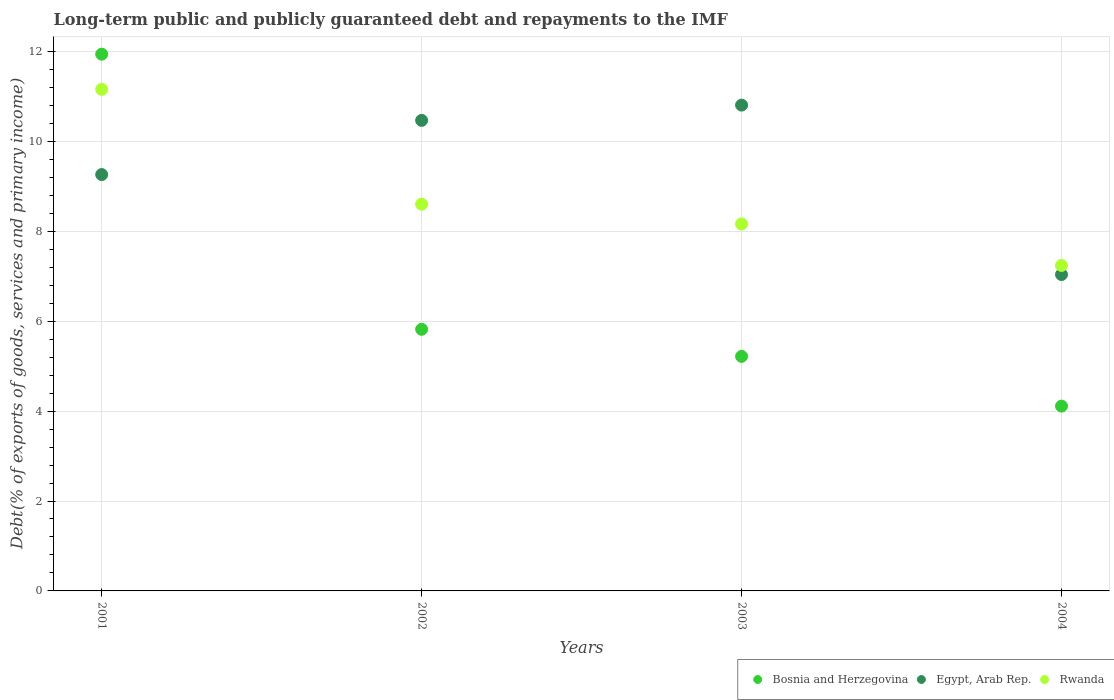How many different coloured dotlines are there?
Offer a terse response. 3. Is the number of dotlines equal to the number of legend labels?
Your answer should be compact. Yes. What is the debt and repayments in Egypt, Arab Rep. in 2003?
Your answer should be very brief. 10.81. Across all years, what is the maximum debt and repayments in Rwanda?
Offer a very short reply. 11.16. Across all years, what is the minimum debt and repayments in Rwanda?
Offer a terse response. 7.24. What is the total debt and repayments in Bosnia and Herzegovina in the graph?
Keep it short and to the point. 27.09. What is the difference between the debt and repayments in Rwanda in 2001 and that in 2004?
Keep it short and to the point. 3.92. What is the difference between the debt and repayments in Bosnia and Herzegovina in 2004 and the debt and repayments in Egypt, Arab Rep. in 2003?
Offer a very short reply. -6.7. What is the average debt and repayments in Bosnia and Herzegovina per year?
Offer a very short reply. 6.77. In the year 2004, what is the difference between the debt and repayments in Rwanda and debt and repayments in Egypt, Arab Rep.?
Give a very brief answer. 0.2. In how many years, is the debt and repayments in Rwanda greater than 10.4 %?
Ensure brevity in your answer.  1. What is the ratio of the debt and repayments in Egypt, Arab Rep. in 2002 to that in 2003?
Provide a short and direct response. 0.97. Is the debt and repayments in Bosnia and Herzegovina in 2001 less than that in 2002?
Your answer should be compact. No. What is the difference between the highest and the second highest debt and repayments in Bosnia and Herzegovina?
Your response must be concise. 6.12. What is the difference between the highest and the lowest debt and repayments in Bosnia and Herzegovina?
Provide a short and direct response. 7.83. In how many years, is the debt and repayments in Bosnia and Herzegovina greater than the average debt and repayments in Bosnia and Herzegovina taken over all years?
Your response must be concise. 1. Does the debt and repayments in Egypt, Arab Rep. monotonically increase over the years?
Provide a short and direct response. No. Is the debt and repayments in Rwanda strictly greater than the debt and repayments in Egypt, Arab Rep. over the years?
Provide a succinct answer. No. Is the debt and repayments in Bosnia and Herzegovina strictly less than the debt and repayments in Egypt, Arab Rep. over the years?
Make the answer very short. No. How many dotlines are there?
Offer a very short reply. 3. Are the values on the major ticks of Y-axis written in scientific E-notation?
Offer a terse response. No. Does the graph contain any zero values?
Your answer should be very brief. No. Where does the legend appear in the graph?
Keep it short and to the point. Bottom right. What is the title of the graph?
Provide a short and direct response. Long-term public and publicly guaranteed debt and repayments to the IMF. Does "Tonga" appear as one of the legend labels in the graph?
Give a very brief answer. No. What is the label or title of the X-axis?
Offer a very short reply. Years. What is the label or title of the Y-axis?
Give a very brief answer. Debt(% of exports of goods, services and primary income). What is the Debt(% of exports of goods, services and primary income) in Bosnia and Herzegovina in 2001?
Provide a succinct answer. 11.94. What is the Debt(% of exports of goods, services and primary income) in Egypt, Arab Rep. in 2001?
Your answer should be very brief. 9.26. What is the Debt(% of exports of goods, services and primary income) of Rwanda in 2001?
Give a very brief answer. 11.16. What is the Debt(% of exports of goods, services and primary income) of Bosnia and Herzegovina in 2002?
Ensure brevity in your answer.  5.82. What is the Debt(% of exports of goods, services and primary income) of Egypt, Arab Rep. in 2002?
Your answer should be very brief. 10.47. What is the Debt(% of exports of goods, services and primary income) in Rwanda in 2002?
Give a very brief answer. 8.6. What is the Debt(% of exports of goods, services and primary income) of Bosnia and Herzegovina in 2003?
Offer a very short reply. 5.22. What is the Debt(% of exports of goods, services and primary income) in Egypt, Arab Rep. in 2003?
Offer a very short reply. 10.81. What is the Debt(% of exports of goods, services and primary income) of Rwanda in 2003?
Make the answer very short. 8.16. What is the Debt(% of exports of goods, services and primary income) of Bosnia and Herzegovina in 2004?
Provide a short and direct response. 4.11. What is the Debt(% of exports of goods, services and primary income) of Egypt, Arab Rep. in 2004?
Make the answer very short. 7.04. What is the Debt(% of exports of goods, services and primary income) of Rwanda in 2004?
Your answer should be very brief. 7.24. Across all years, what is the maximum Debt(% of exports of goods, services and primary income) of Bosnia and Herzegovina?
Keep it short and to the point. 11.94. Across all years, what is the maximum Debt(% of exports of goods, services and primary income) of Egypt, Arab Rep.?
Make the answer very short. 10.81. Across all years, what is the maximum Debt(% of exports of goods, services and primary income) in Rwanda?
Give a very brief answer. 11.16. Across all years, what is the minimum Debt(% of exports of goods, services and primary income) in Bosnia and Herzegovina?
Your answer should be very brief. 4.11. Across all years, what is the minimum Debt(% of exports of goods, services and primary income) of Egypt, Arab Rep.?
Your response must be concise. 7.04. Across all years, what is the minimum Debt(% of exports of goods, services and primary income) of Rwanda?
Offer a very short reply. 7.24. What is the total Debt(% of exports of goods, services and primary income) of Bosnia and Herzegovina in the graph?
Offer a very short reply. 27.09. What is the total Debt(% of exports of goods, services and primary income) in Egypt, Arab Rep. in the graph?
Make the answer very short. 37.58. What is the total Debt(% of exports of goods, services and primary income) of Rwanda in the graph?
Your response must be concise. 35.17. What is the difference between the Debt(% of exports of goods, services and primary income) of Bosnia and Herzegovina in 2001 and that in 2002?
Your answer should be very brief. 6.12. What is the difference between the Debt(% of exports of goods, services and primary income) of Egypt, Arab Rep. in 2001 and that in 2002?
Ensure brevity in your answer.  -1.21. What is the difference between the Debt(% of exports of goods, services and primary income) of Rwanda in 2001 and that in 2002?
Keep it short and to the point. 2.55. What is the difference between the Debt(% of exports of goods, services and primary income) of Bosnia and Herzegovina in 2001 and that in 2003?
Give a very brief answer. 6.72. What is the difference between the Debt(% of exports of goods, services and primary income) in Egypt, Arab Rep. in 2001 and that in 2003?
Make the answer very short. -1.55. What is the difference between the Debt(% of exports of goods, services and primary income) of Rwanda in 2001 and that in 2003?
Offer a terse response. 2.99. What is the difference between the Debt(% of exports of goods, services and primary income) of Bosnia and Herzegovina in 2001 and that in 2004?
Your response must be concise. 7.83. What is the difference between the Debt(% of exports of goods, services and primary income) of Egypt, Arab Rep. in 2001 and that in 2004?
Your response must be concise. 2.22. What is the difference between the Debt(% of exports of goods, services and primary income) in Rwanda in 2001 and that in 2004?
Your answer should be very brief. 3.92. What is the difference between the Debt(% of exports of goods, services and primary income) in Bosnia and Herzegovina in 2002 and that in 2003?
Your answer should be compact. 0.6. What is the difference between the Debt(% of exports of goods, services and primary income) in Egypt, Arab Rep. in 2002 and that in 2003?
Offer a terse response. -0.34. What is the difference between the Debt(% of exports of goods, services and primary income) in Rwanda in 2002 and that in 2003?
Ensure brevity in your answer.  0.44. What is the difference between the Debt(% of exports of goods, services and primary income) in Bosnia and Herzegovina in 2002 and that in 2004?
Your response must be concise. 1.71. What is the difference between the Debt(% of exports of goods, services and primary income) in Egypt, Arab Rep. in 2002 and that in 2004?
Give a very brief answer. 3.43. What is the difference between the Debt(% of exports of goods, services and primary income) of Rwanda in 2002 and that in 2004?
Ensure brevity in your answer.  1.36. What is the difference between the Debt(% of exports of goods, services and primary income) in Bosnia and Herzegovina in 2003 and that in 2004?
Keep it short and to the point. 1.11. What is the difference between the Debt(% of exports of goods, services and primary income) in Egypt, Arab Rep. in 2003 and that in 2004?
Give a very brief answer. 3.77. What is the difference between the Debt(% of exports of goods, services and primary income) of Rwanda in 2003 and that in 2004?
Ensure brevity in your answer.  0.92. What is the difference between the Debt(% of exports of goods, services and primary income) in Bosnia and Herzegovina in 2001 and the Debt(% of exports of goods, services and primary income) in Egypt, Arab Rep. in 2002?
Ensure brevity in your answer.  1.47. What is the difference between the Debt(% of exports of goods, services and primary income) in Bosnia and Herzegovina in 2001 and the Debt(% of exports of goods, services and primary income) in Rwanda in 2002?
Make the answer very short. 3.34. What is the difference between the Debt(% of exports of goods, services and primary income) of Egypt, Arab Rep. in 2001 and the Debt(% of exports of goods, services and primary income) of Rwanda in 2002?
Provide a short and direct response. 0.66. What is the difference between the Debt(% of exports of goods, services and primary income) of Bosnia and Herzegovina in 2001 and the Debt(% of exports of goods, services and primary income) of Egypt, Arab Rep. in 2003?
Make the answer very short. 1.13. What is the difference between the Debt(% of exports of goods, services and primary income) in Bosnia and Herzegovina in 2001 and the Debt(% of exports of goods, services and primary income) in Rwanda in 2003?
Your response must be concise. 3.78. What is the difference between the Debt(% of exports of goods, services and primary income) in Egypt, Arab Rep. in 2001 and the Debt(% of exports of goods, services and primary income) in Rwanda in 2003?
Offer a very short reply. 1.1. What is the difference between the Debt(% of exports of goods, services and primary income) in Bosnia and Herzegovina in 2001 and the Debt(% of exports of goods, services and primary income) in Egypt, Arab Rep. in 2004?
Keep it short and to the point. 4.9. What is the difference between the Debt(% of exports of goods, services and primary income) in Bosnia and Herzegovina in 2001 and the Debt(% of exports of goods, services and primary income) in Rwanda in 2004?
Ensure brevity in your answer.  4.7. What is the difference between the Debt(% of exports of goods, services and primary income) in Egypt, Arab Rep. in 2001 and the Debt(% of exports of goods, services and primary income) in Rwanda in 2004?
Provide a succinct answer. 2.02. What is the difference between the Debt(% of exports of goods, services and primary income) of Bosnia and Herzegovina in 2002 and the Debt(% of exports of goods, services and primary income) of Egypt, Arab Rep. in 2003?
Your answer should be compact. -4.99. What is the difference between the Debt(% of exports of goods, services and primary income) of Bosnia and Herzegovina in 2002 and the Debt(% of exports of goods, services and primary income) of Rwanda in 2003?
Make the answer very short. -2.34. What is the difference between the Debt(% of exports of goods, services and primary income) in Egypt, Arab Rep. in 2002 and the Debt(% of exports of goods, services and primary income) in Rwanda in 2003?
Give a very brief answer. 2.3. What is the difference between the Debt(% of exports of goods, services and primary income) in Bosnia and Herzegovina in 2002 and the Debt(% of exports of goods, services and primary income) in Egypt, Arab Rep. in 2004?
Ensure brevity in your answer.  -1.22. What is the difference between the Debt(% of exports of goods, services and primary income) in Bosnia and Herzegovina in 2002 and the Debt(% of exports of goods, services and primary income) in Rwanda in 2004?
Keep it short and to the point. -1.42. What is the difference between the Debt(% of exports of goods, services and primary income) in Egypt, Arab Rep. in 2002 and the Debt(% of exports of goods, services and primary income) in Rwanda in 2004?
Provide a succinct answer. 3.23. What is the difference between the Debt(% of exports of goods, services and primary income) in Bosnia and Herzegovina in 2003 and the Debt(% of exports of goods, services and primary income) in Egypt, Arab Rep. in 2004?
Keep it short and to the point. -1.82. What is the difference between the Debt(% of exports of goods, services and primary income) in Bosnia and Herzegovina in 2003 and the Debt(% of exports of goods, services and primary income) in Rwanda in 2004?
Offer a terse response. -2.02. What is the difference between the Debt(% of exports of goods, services and primary income) in Egypt, Arab Rep. in 2003 and the Debt(% of exports of goods, services and primary income) in Rwanda in 2004?
Provide a succinct answer. 3.57. What is the average Debt(% of exports of goods, services and primary income) of Bosnia and Herzegovina per year?
Keep it short and to the point. 6.77. What is the average Debt(% of exports of goods, services and primary income) in Egypt, Arab Rep. per year?
Offer a terse response. 9.39. What is the average Debt(% of exports of goods, services and primary income) in Rwanda per year?
Keep it short and to the point. 8.79. In the year 2001, what is the difference between the Debt(% of exports of goods, services and primary income) of Bosnia and Herzegovina and Debt(% of exports of goods, services and primary income) of Egypt, Arab Rep.?
Provide a succinct answer. 2.68. In the year 2001, what is the difference between the Debt(% of exports of goods, services and primary income) in Bosnia and Herzegovina and Debt(% of exports of goods, services and primary income) in Rwanda?
Your answer should be very brief. 0.78. In the year 2001, what is the difference between the Debt(% of exports of goods, services and primary income) in Egypt, Arab Rep. and Debt(% of exports of goods, services and primary income) in Rwanda?
Offer a terse response. -1.9. In the year 2002, what is the difference between the Debt(% of exports of goods, services and primary income) in Bosnia and Herzegovina and Debt(% of exports of goods, services and primary income) in Egypt, Arab Rep.?
Provide a succinct answer. -4.65. In the year 2002, what is the difference between the Debt(% of exports of goods, services and primary income) in Bosnia and Herzegovina and Debt(% of exports of goods, services and primary income) in Rwanda?
Your response must be concise. -2.78. In the year 2002, what is the difference between the Debt(% of exports of goods, services and primary income) in Egypt, Arab Rep. and Debt(% of exports of goods, services and primary income) in Rwanda?
Your answer should be compact. 1.86. In the year 2003, what is the difference between the Debt(% of exports of goods, services and primary income) of Bosnia and Herzegovina and Debt(% of exports of goods, services and primary income) of Egypt, Arab Rep.?
Make the answer very short. -5.59. In the year 2003, what is the difference between the Debt(% of exports of goods, services and primary income) of Bosnia and Herzegovina and Debt(% of exports of goods, services and primary income) of Rwanda?
Make the answer very short. -2.95. In the year 2003, what is the difference between the Debt(% of exports of goods, services and primary income) of Egypt, Arab Rep. and Debt(% of exports of goods, services and primary income) of Rwanda?
Provide a short and direct response. 2.64. In the year 2004, what is the difference between the Debt(% of exports of goods, services and primary income) of Bosnia and Herzegovina and Debt(% of exports of goods, services and primary income) of Egypt, Arab Rep.?
Ensure brevity in your answer.  -2.93. In the year 2004, what is the difference between the Debt(% of exports of goods, services and primary income) in Bosnia and Herzegovina and Debt(% of exports of goods, services and primary income) in Rwanda?
Keep it short and to the point. -3.13. In the year 2004, what is the difference between the Debt(% of exports of goods, services and primary income) of Egypt, Arab Rep. and Debt(% of exports of goods, services and primary income) of Rwanda?
Give a very brief answer. -0.2. What is the ratio of the Debt(% of exports of goods, services and primary income) of Bosnia and Herzegovina in 2001 to that in 2002?
Ensure brevity in your answer.  2.05. What is the ratio of the Debt(% of exports of goods, services and primary income) in Egypt, Arab Rep. in 2001 to that in 2002?
Your answer should be compact. 0.88. What is the ratio of the Debt(% of exports of goods, services and primary income) of Rwanda in 2001 to that in 2002?
Offer a very short reply. 1.3. What is the ratio of the Debt(% of exports of goods, services and primary income) of Bosnia and Herzegovina in 2001 to that in 2003?
Give a very brief answer. 2.29. What is the ratio of the Debt(% of exports of goods, services and primary income) in Egypt, Arab Rep. in 2001 to that in 2003?
Give a very brief answer. 0.86. What is the ratio of the Debt(% of exports of goods, services and primary income) in Rwanda in 2001 to that in 2003?
Provide a succinct answer. 1.37. What is the ratio of the Debt(% of exports of goods, services and primary income) of Bosnia and Herzegovina in 2001 to that in 2004?
Make the answer very short. 2.9. What is the ratio of the Debt(% of exports of goods, services and primary income) of Egypt, Arab Rep. in 2001 to that in 2004?
Your response must be concise. 1.32. What is the ratio of the Debt(% of exports of goods, services and primary income) in Rwanda in 2001 to that in 2004?
Provide a short and direct response. 1.54. What is the ratio of the Debt(% of exports of goods, services and primary income) in Bosnia and Herzegovina in 2002 to that in 2003?
Provide a succinct answer. 1.12. What is the ratio of the Debt(% of exports of goods, services and primary income) in Egypt, Arab Rep. in 2002 to that in 2003?
Provide a short and direct response. 0.97. What is the ratio of the Debt(% of exports of goods, services and primary income) of Rwanda in 2002 to that in 2003?
Keep it short and to the point. 1.05. What is the ratio of the Debt(% of exports of goods, services and primary income) in Bosnia and Herzegovina in 2002 to that in 2004?
Your response must be concise. 1.42. What is the ratio of the Debt(% of exports of goods, services and primary income) of Egypt, Arab Rep. in 2002 to that in 2004?
Offer a terse response. 1.49. What is the ratio of the Debt(% of exports of goods, services and primary income) of Rwanda in 2002 to that in 2004?
Your answer should be compact. 1.19. What is the ratio of the Debt(% of exports of goods, services and primary income) of Bosnia and Herzegovina in 2003 to that in 2004?
Your answer should be very brief. 1.27. What is the ratio of the Debt(% of exports of goods, services and primary income) in Egypt, Arab Rep. in 2003 to that in 2004?
Provide a succinct answer. 1.54. What is the ratio of the Debt(% of exports of goods, services and primary income) in Rwanda in 2003 to that in 2004?
Ensure brevity in your answer.  1.13. What is the difference between the highest and the second highest Debt(% of exports of goods, services and primary income) in Bosnia and Herzegovina?
Offer a very short reply. 6.12. What is the difference between the highest and the second highest Debt(% of exports of goods, services and primary income) of Egypt, Arab Rep.?
Provide a succinct answer. 0.34. What is the difference between the highest and the second highest Debt(% of exports of goods, services and primary income) in Rwanda?
Provide a short and direct response. 2.55. What is the difference between the highest and the lowest Debt(% of exports of goods, services and primary income) of Bosnia and Herzegovina?
Provide a succinct answer. 7.83. What is the difference between the highest and the lowest Debt(% of exports of goods, services and primary income) in Egypt, Arab Rep.?
Ensure brevity in your answer.  3.77. What is the difference between the highest and the lowest Debt(% of exports of goods, services and primary income) in Rwanda?
Your answer should be very brief. 3.92. 